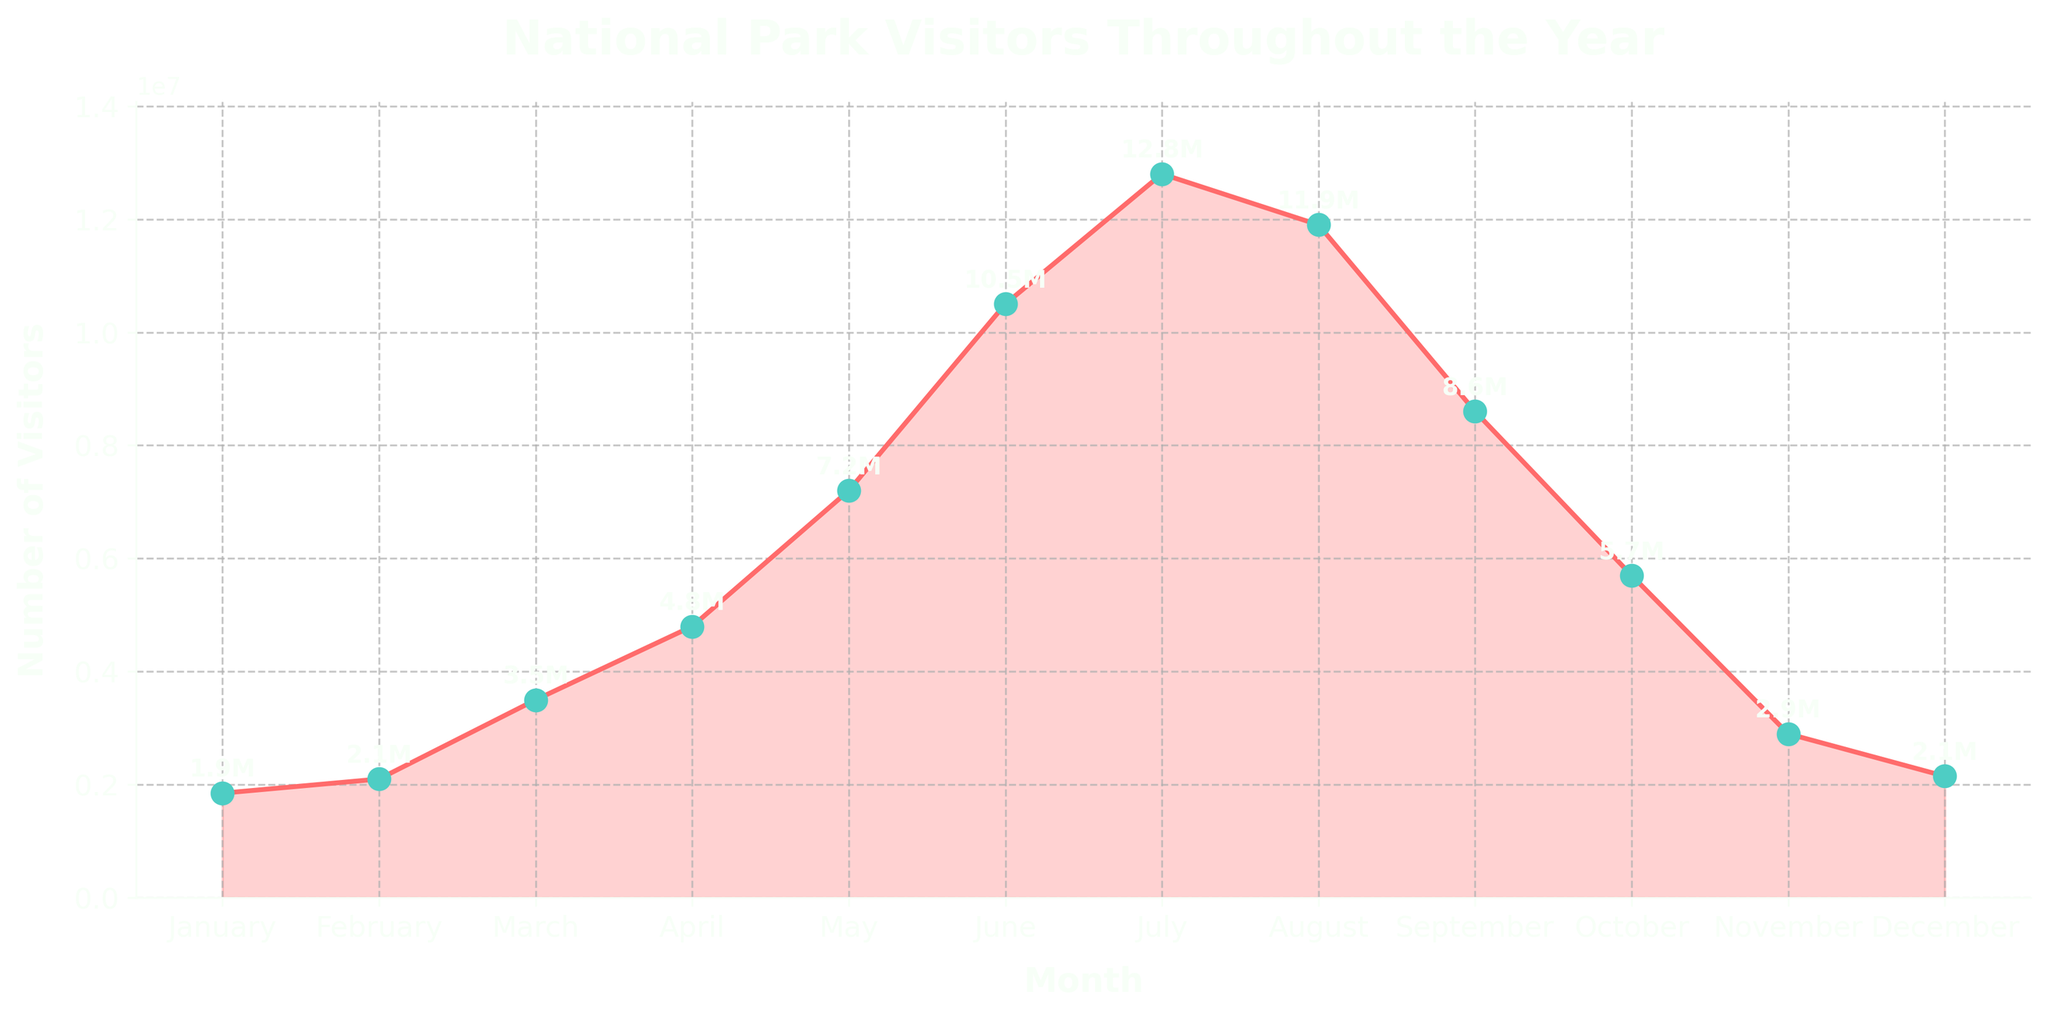Which month has the highest number of visitors? To find the month with the highest number of visitors, look for the peak in the line chart. The highest point is in July with 12.8 million visitors.
Answer: July What is the total number of visitors from June to August? Sum the number of visitors for June, July, and August. June has 10.5 million, July has 12.8 million, and August has 11.9 million. The total is 10.5 + 12.8 + 11.9 = 35.2 million.
Answer: 35.2 million Which month shows the largest increase in visitors compared to the previous month? Calculate the difference in visitors between consecutive months and find the largest increase. The largest jump is from April (4.8 million) to May (7.2 million), which is an increase of 2.4 million visitors.
Answer: May How do the visitor numbers in January compare to those in December? Compare the visitor numbers visually or numerically. January has 1.85 million visitors while December has 2.15 million visitors. December has more visitors than January.
Answer: December has more visitors What is the average number of visitors per month? Sum all the monthly visitor numbers and divide by 12. The total visit number is 74.25 million. Average = 74.25 / 12 ≈ 6.1875 million.
Answer: 6.19 million During which season do national parks see the most visitors? Identify the months for each season and sum their visitor numbers. The numbers for June, July, and August (summer) are highest with a total of 10.5 + 12.8 + 11.9 = 35.2 million.
Answer: Summer What is the difference in visitor numbers between the months with the highest and lowest attendance? Subtract the number of visitors in the month with the lowest attendance (January: 1.85 million) from the month with the highest attendance (July: 12.8 million). Difference = 12.8 - 1.85 = 10.95 million.
Answer: 10.95 million In which quarter is the highest number of visitors recorded? Sum the visitor numbers for each quarter and compare. Q1 (Jan-Mar): 7.45 million, Q2 (Apr-Jun): 22.1 million, Q3 (Jul-Sep): 33.5 million, Q4 (Oct-Dec): 10.05 million. Q3 has the highest with 33.5 million.
Answer: Q3 Is there any month where the visitor number exceeds 10 million? Look at each month's visitor numbers to see if any exceed 10 million. Both July (12.8 million) and August (11.9 million) exceed 10 million.
Answer: Yes How does June's visitor number compare to April's? Compare the visitor numbers visually or numerically. June has 10.5 million visitors while April has 4.8 million. June has significantly more visitors.
Answer: June has more visitors 